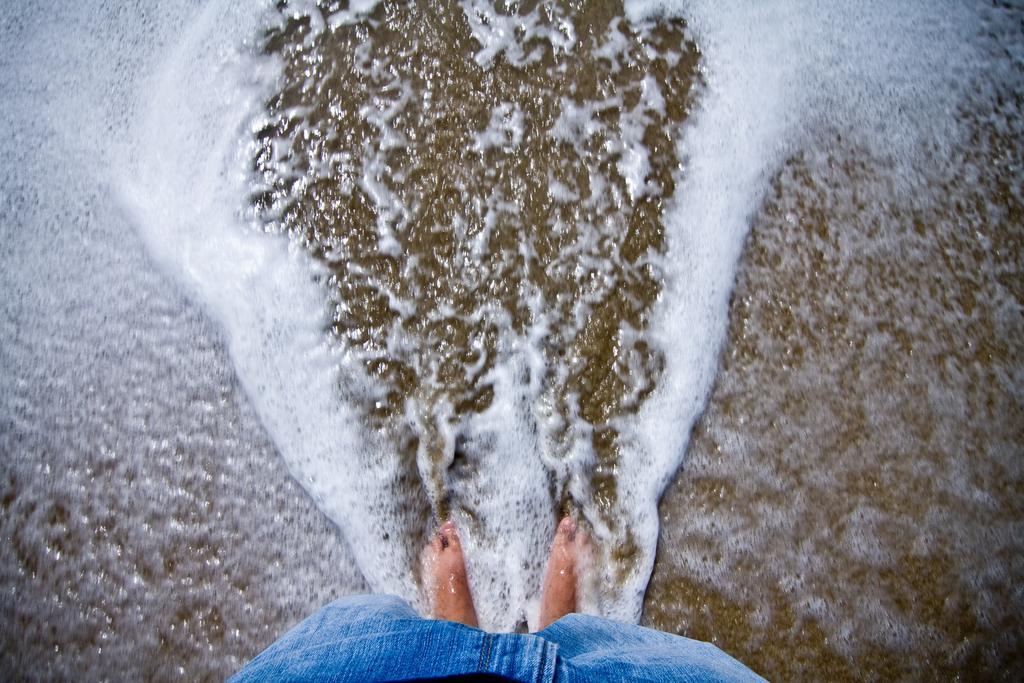Describe this image in one or two sentences. In foreground of the image we can see a person standing in water and wearing a blue color paint. In the middle of the image we can see some water and sand. On top of the image we can see water and sand. 